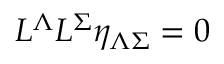Convert formula to latex. <formula><loc_0><loc_0><loc_500><loc_500>L ^ { \Lambda } L ^ { \Sigma } \eta _ { \Lambda \Sigma } = 0</formula> 